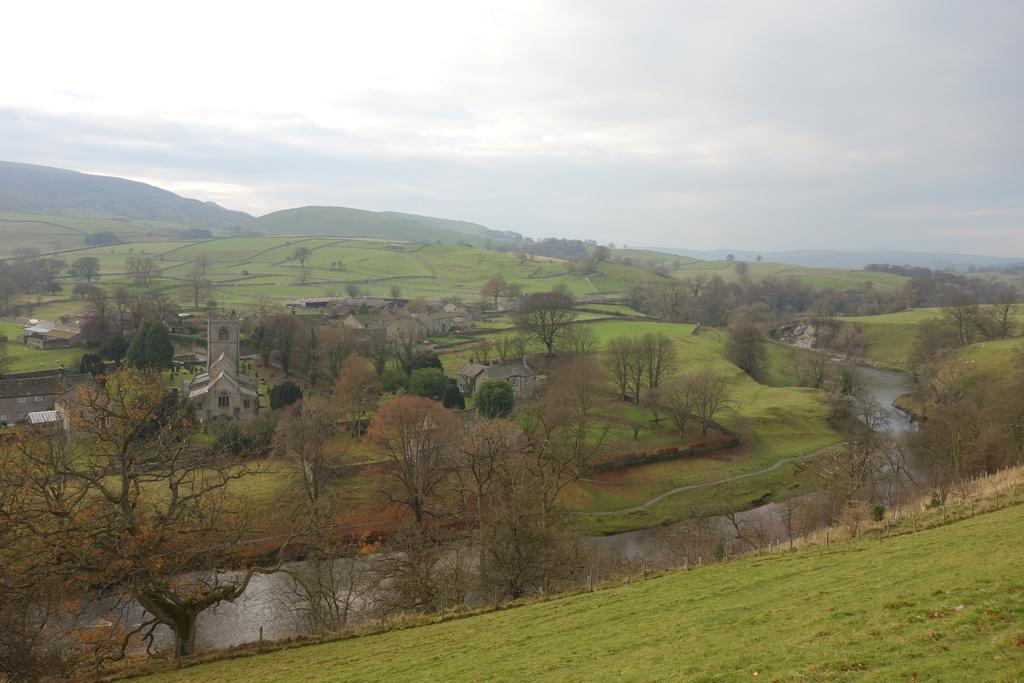What type of vegetation can be seen in the image? There are trees in the image. What type of ground cover is present in the image? There is grass in the image. What natural feature is visible in the image? There is water visible in the image. What type of man-made structures can be seen in the image? There are buildings in the image. What geographical features are visible in the background of the image? There are hills visible in the background of the image. What part of the natural environment is visible in the background of the image? The sky is visible in the background of the image. Can you tell me how many plants the person is holding in the image? There is no person holding any plants in the image. What type of cushion is visible on the ground in the image? There is no cushion present in the image. 